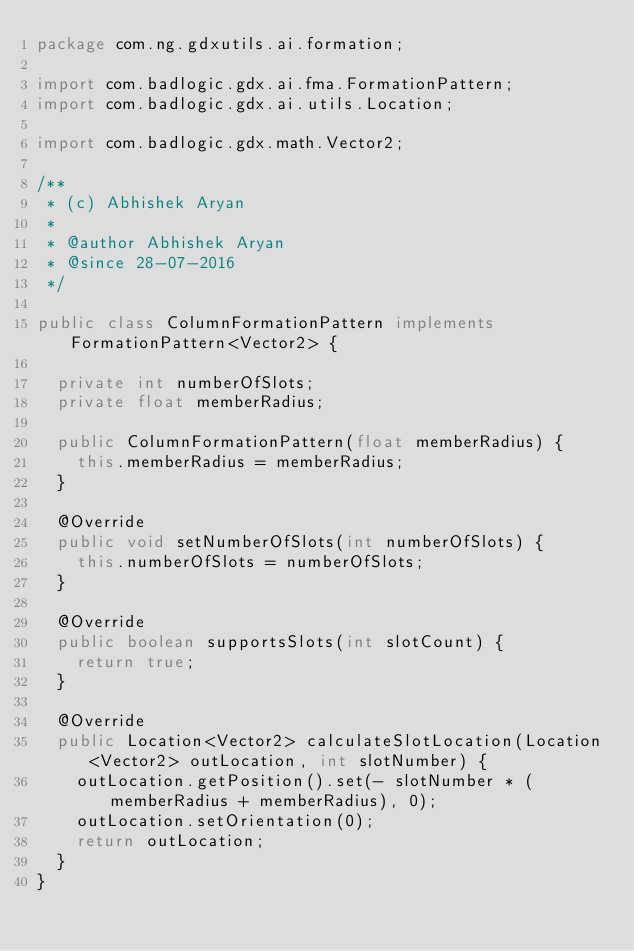<code> <loc_0><loc_0><loc_500><loc_500><_Java_>package com.ng.gdxutils.ai.formation;

import com.badlogic.gdx.ai.fma.FormationPattern;
import com.badlogic.gdx.ai.utils.Location;

import com.badlogic.gdx.math.Vector2;

/**
 * (c) Abhishek Aryan
 *
 * @author Abhishek Aryan
 * @since 28-07-2016
 */

public class ColumnFormationPattern implements FormationPattern<Vector2> {

	private int numberOfSlots;
	private float memberRadius;

	public ColumnFormationPattern(float memberRadius) {
		this.memberRadius = memberRadius;
	}

	@Override
	public void setNumberOfSlots(int numberOfSlots) {
		this.numberOfSlots = numberOfSlots;
	}

	@Override
	public boolean supportsSlots(int slotCount) {
		return true;
	}

	@Override
	public Location<Vector2> calculateSlotLocation(Location<Vector2> outLocation, int slotNumber) {
		outLocation.getPosition().set(- slotNumber * (memberRadius + memberRadius), 0);
		outLocation.setOrientation(0);
		return outLocation;
	}
}
</code> 